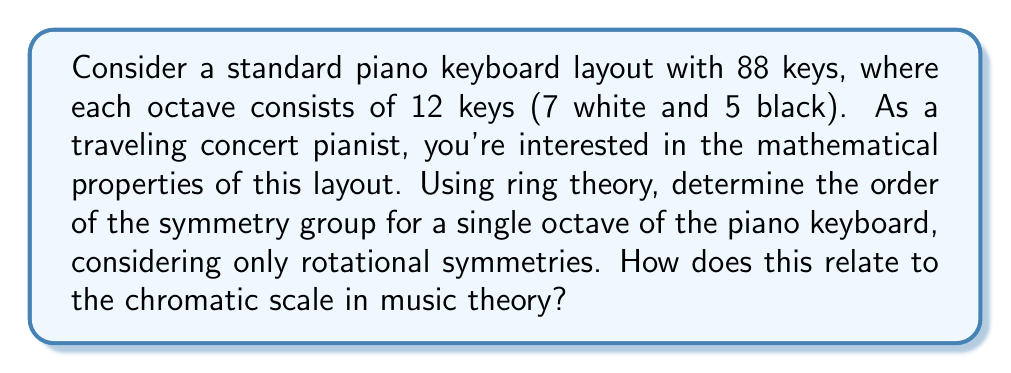Can you solve this math problem? Let's approach this step-by-step:

1) First, we need to understand what we're analyzing. A single octave of a piano keyboard consists of 12 keys in the following pattern:
   White, Black, White, Black, White, White, Black, White, Black, White, Black, White

2) In ring theory, we can consider this pattern as elements of a cyclic group $C_{12}$, where each element represents a key, and the group operation is addition modulo 12.

3) The symmetry group we're looking for consists of rotational symmetries. These are operations that rotate the keyboard pattern and result in the same pattern.

4) To find these symmetries, we need to identify rotations that preserve the pattern. Let's number the keys from 0 to 11:

   0 (C), 1 (C#), 2 (D), 3 (D#), 4 (E), 5 (F), 6 (F#), 7 (G), 8 (G#), 9 (A), 10 (A#), 11 (B)

5) The pattern-preserving rotations are:
   - Rotation by 0 (identity)
   - Rotation by 12 (full rotation, same as identity)

6) Any other rotation would disrupt the pattern of white and black keys.

7) Therefore, the symmetry group consists of only one element: the identity operation.

8) In group theory terms, this is isomorphic to the trivial group with one element, often denoted as $C_1$.

9) The order of a group is the number of elements it contains. In this case, the order is 1.

10) This relates to music theory in an interesting way. The fact that there's only one symmetry (the identity) reflects the unique structure of the chromatic scale. Each of the 12 tones in an octave has a distinct role, and shifting the pattern would create a fundamentally different musical structure.
Answer: The order of the symmetry group for a single octave of the piano keyboard, considering only rotational symmetries, is 1. This reflects the unique structure of the chromatic scale, where each of the 12 tones has a distinct musical function. 